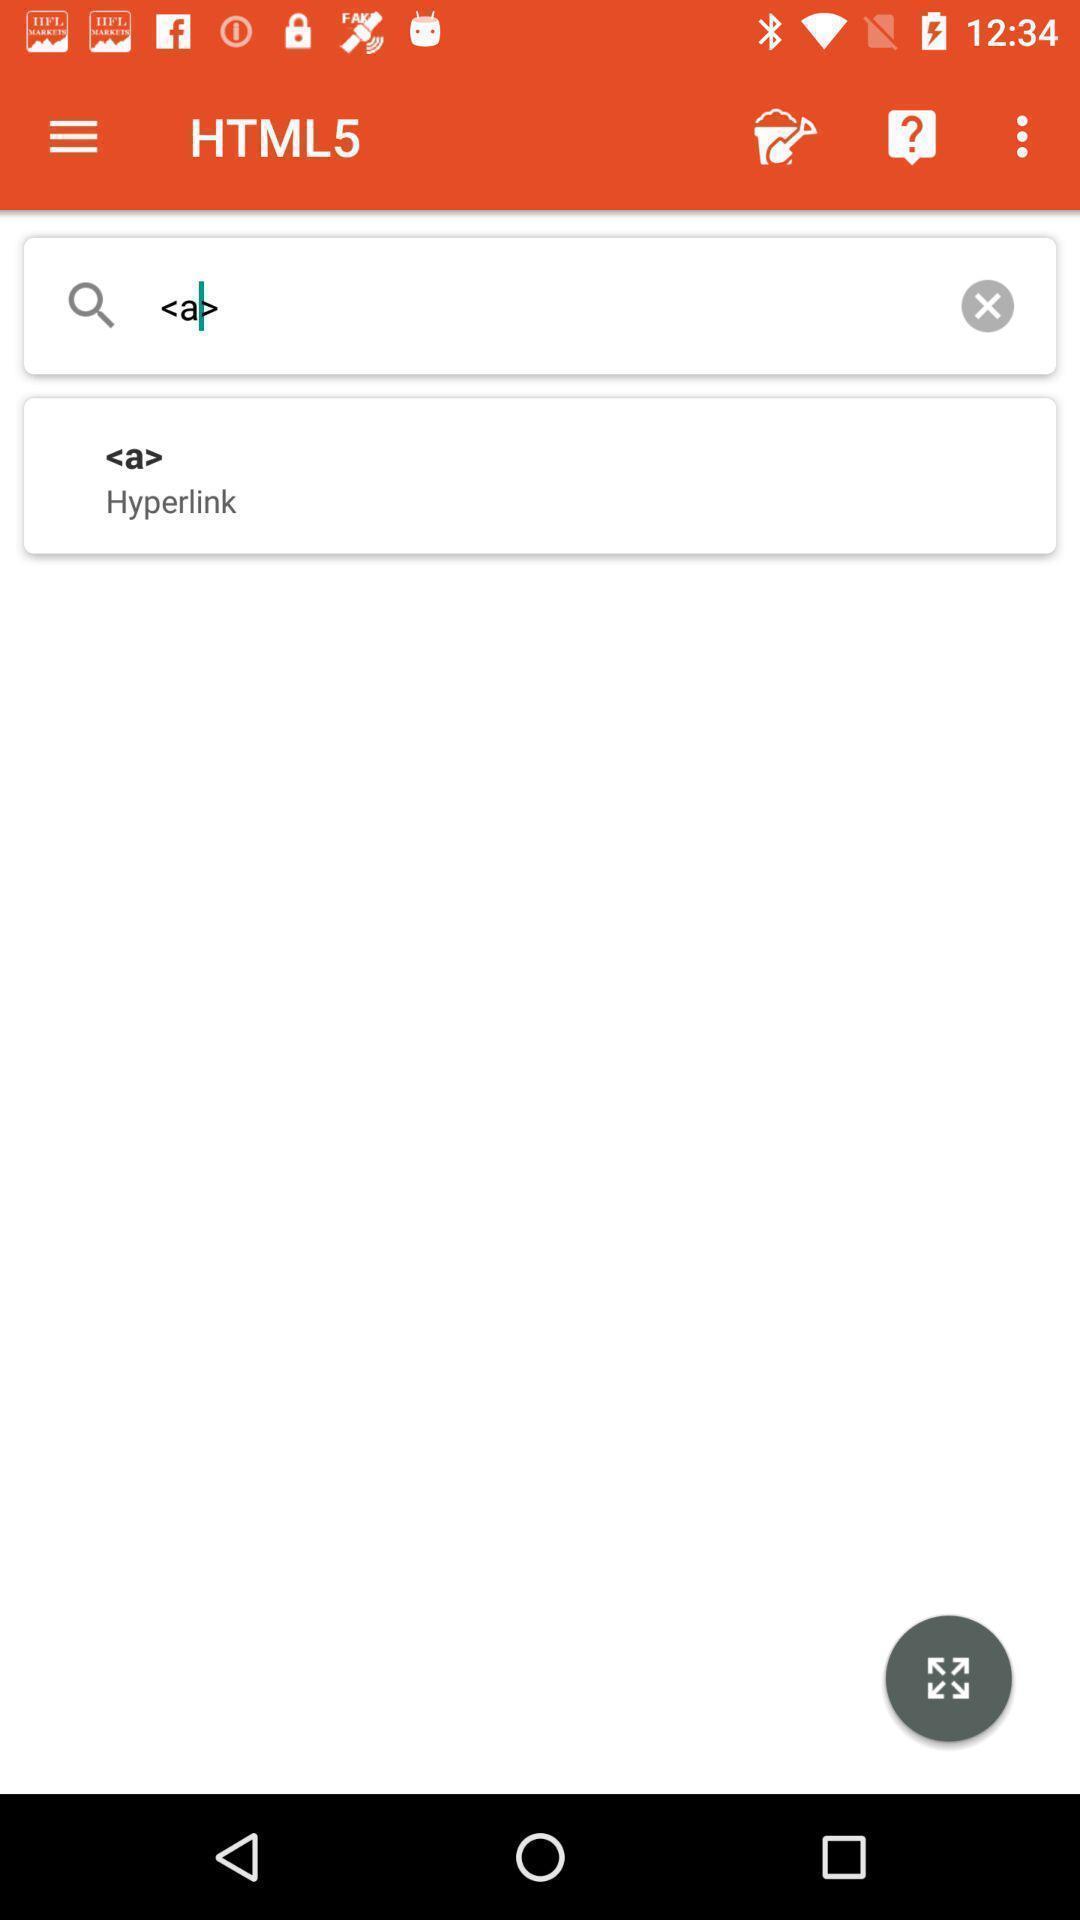Provide a textual representation of this image. Search bar to search for tags in app. 